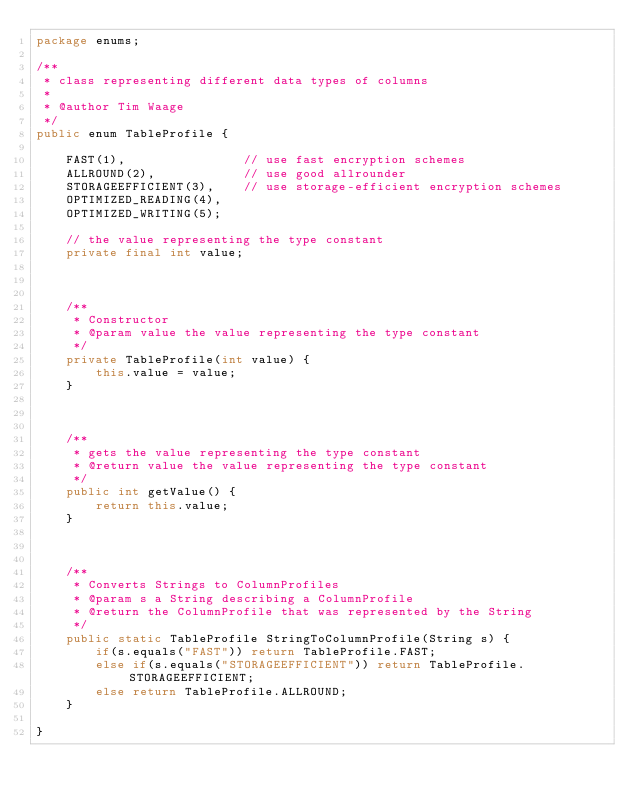<code> <loc_0><loc_0><loc_500><loc_500><_Java_>package enums;

/**
 * class representing different data types of columns
 * 
 * @author Tim Waage
 */
public enum TableProfile {

	FAST(1),				// use fast encryption schemes
    ALLROUND(2),			// use good allrounder
    STORAGEEFFICIENT(3),	// use storage-efficient encryption schemes
    OPTIMIZED_READING(4),
    OPTIMIZED_WRITING(5);
	
	// the value representing the type constant
    private final int value;

    
    
    /**
     * Constructor
     * @param value the value representing the type constant
     */
    private TableProfile(int value) {
        this.value = value;
    }

    
    
    /**
     * gets the value representing the type constant
     * @return value the value representing the type constant
     */
    public int getValue() {
        return this.value;
    }
    
    
    
    /**
     * Converts Strings to ColumnProfiles
     * @param s a String describing a ColumnProfile
     * @return the ColumnProfile that was represented by the String
     */
    public static TableProfile StringToColumnProfile(String s) {
    	if(s.equals("FAST")) return TableProfile.FAST;
    	else if(s.equals("STORAGEEFFICIENT")) return TableProfile.STORAGEEFFICIENT;
    	else return TableProfile.ALLROUND;
    }
	
}
</code> 